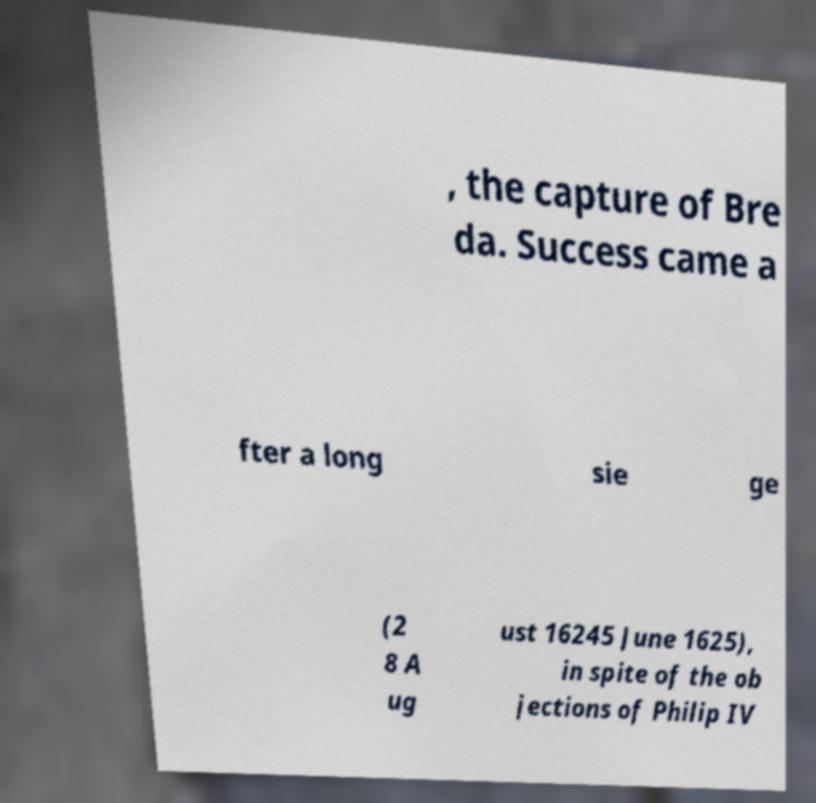Could you assist in decoding the text presented in this image and type it out clearly? , the capture of Bre da. Success came a fter a long sie ge (2 8 A ug ust 16245 June 1625), in spite of the ob jections of Philip IV 